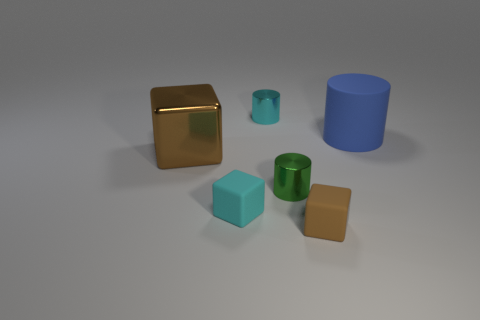Subtract all red cylinders. Subtract all gray spheres. How many cylinders are left? 3 Add 4 big red cubes. How many objects exist? 10 Add 4 big blue things. How many big blue things exist? 5 Subtract 1 brown blocks. How many objects are left? 5 Subtract all small green matte balls. Subtract all tiny brown rubber objects. How many objects are left? 5 Add 5 rubber cubes. How many rubber cubes are left? 7 